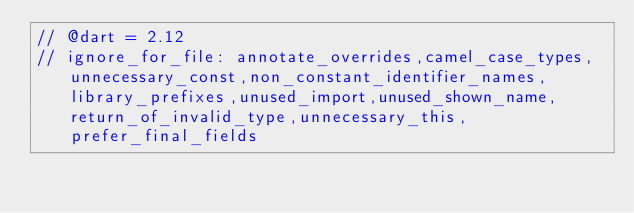Convert code to text. <code><loc_0><loc_0><loc_500><loc_500><_Dart_>// @dart = 2.12
// ignore_for_file: annotate_overrides,camel_case_types,unnecessary_const,non_constant_identifier_names,library_prefixes,unused_import,unused_shown_name,return_of_invalid_type,unnecessary_this,prefer_final_fields

</code> 